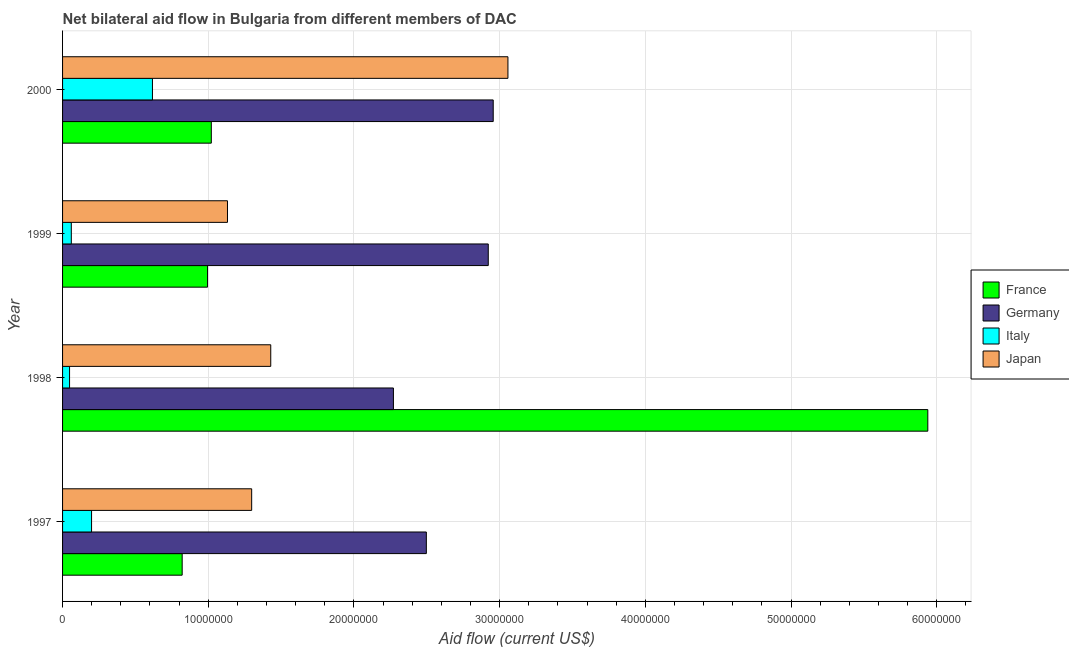How many different coloured bars are there?
Provide a succinct answer. 4. How many groups of bars are there?
Keep it short and to the point. 4. Are the number of bars per tick equal to the number of legend labels?
Your response must be concise. Yes. How many bars are there on the 2nd tick from the bottom?
Provide a succinct answer. 4. What is the label of the 3rd group of bars from the top?
Provide a short and direct response. 1998. In how many cases, is the number of bars for a given year not equal to the number of legend labels?
Provide a short and direct response. 0. What is the amount of aid given by france in 1999?
Give a very brief answer. 9.95e+06. Across all years, what is the maximum amount of aid given by france?
Ensure brevity in your answer.  5.94e+07. Across all years, what is the minimum amount of aid given by germany?
Give a very brief answer. 2.27e+07. In which year was the amount of aid given by germany maximum?
Ensure brevity in your answer.  2000. In which year was the amount of aid given by germany minimum?
Offer a very short reply. 1998. What is the total amount of aid given by italy in the graph?
Make the answer very short. 9.24e+06. What is the difference between the amount of aid given by italy in 1997 and that in 1998?
Provide a short and direct response. 1.51e+06. What is the difference between the amount of aid given by germany in 1997 and the amount of aid given by italy in 1999?
Make the answer very short. 2.44e+07. What is the average amount of aid given by germany per year?
Provide a succinct answer. 2.66e+07. In the year 1998, what is the difference between the amount of aid given by italy and amount of aid given by japan?
Give a very brief answer. -1.38e+07. In how many years, is the amount of aid given by japan greater than 24000000 US$?
Make the answer very short. 1. What is the ratio of the amount of aid given by germany in 1998 to that in 1999?
Offer a terse response. 0.78. Is the difference between the amount of aid given by germany in 1998 and 2000 greater than the difference between the amount of aid given by italy in 1998 and 2000?
Your answer should be compact. No. What is the difference between the highest and the second highest amount of aid given by france?
Give a very brief answer. 4.92e+07. What is the difference between the highest and the lowest amount of aid given by germany?
Provide a succinct answer. 6.85e+06. In how many years, is the amount of aid given by france greater than the average amount of aid given by france taken over all years?
Your answer should be very brief. 1. Is the sum of the amount of aid given by italy in 1997 and 2000 greater than the maximum amount of aid given by germany across all years?
Your answer should be compact. No. What does the 1st bar from the bottom in 2000 represents?
Your answer should be compact. France. How many bars are there?
Offer a terse response. 16. Are all the bars in the graph horizontal?
Provide a short and direct response. Yes. What is the difference between two consecutive major ticks on the X-axis?
Give a very brief answer. 1.00e+07. Does the graph contain any zero values?
Provide a short and direct response. No. Does the graph contain grids?
Make the answer very short. Yes. Where does the legend appear in the graph?
Provide a succinct answer. Center right. How many legend labels are there?
Offer a terse response. 4. What is the title of the graph?
Offer a very short reply. Net bilateral aid flow in Bulgaria from different members of DAC. What is the label or title of the Y-axis?
Your response must be concise. Year. What is the Aid flow (current US$) of France in 1997?
Offer a very short reply. 8.21e+06. What is the Aid flow (current US$) in Germany in 1997?
Give a very brief answer. 2.50e+07. What is the Aid flow (current US$) in Italy in 1997?
Your response must be concise. 1.99e+06. What is the Aid flow (current US$) in Japan in 1997?
Keep it short and to the point. 1.30e+07. What is the Aid flow (current US$) of France in 1998?
Offer a very short reply. 5.94e+07. What is the Aid flow (current US$) in Germany in 1998?
Offer a terse response. 2.27e+07. What is the Aid flow (current US$) in Japan in 1998?
Make the answer very short. 1.43e+07. What is the Aid flow (current US$) of France in 1999?
Keep it short and to the point. 9.95e+06. What is the Aid flow (current US$) in Germany in 1999?
Your answer should be very brief. 2.92e+07. What is the Aid flow (current US$) of Italy in 1999?
Offer a very short reply. 6.00e+05. What is the Aid flow (current US$) of Japan in 1999?
Keep it short and to the point. 1.13e+07. What is the Aid flow (current US$) of France in 2000?
Ensure brevity in your answer.  1.02e+07. What is the Aid flow (current US$) of Germany in 2000?
Your response must be concise. 2.96e+07. What is the Aid flow (current US$) of Italy in 2000?
Give a very brief answer. 6.17e+06. What is the Aid flow (current US$) in Japan in 2000?
Give a very brief answer. 3.06e+07. Across all years, what is the maximum Aid flow (current US$) of France?
Provide a short and direct response. 5.94e+07. Across all years, what is the maximum Aid flow (current US$) in Germany?
Offer a terse response. 2.96e+07. Across all years, what is the maximum Aid flow (current US$) of Italy?
Make the answer very short. 6.17e+06. Across all years, what is the maximum Aid flow (current US$) in Japan?
Make the answer very short. 3.06e+07. Across all years, what is the minimum Aid flow (current US$) of France?
Offer a terse response. 8.21e+06. Across all years, what is the minimum Aid flow (current US$) of Germany?
Keep it short and to the point. 2.27e+07. Across all years, what is the minimum Aid flow (current US$) in Italy?
Offer a very short reply. 4.80e+05. Across all years, what is the minimum Aid flow (current US$) in Japan?
Your answer should be very brief. 1.13e+07. What is the total Aid flow (current US$) of France in the graph?
Give a very brief answer. 8.78e+07. What is the total Aid flow (current US$) in Germany in the graph?
Ensure brevity in your answer.  1.06e+08. What is the total Aid flow (current US$) in Italy in the graph?
Make the answer very short. 9.24e+06. What is the total Aid flow (current US$) in Japan in the graph?
Provide a succinct answer. 6.92e+07. What is the difference between the Aid flow (current US$) of France in 1997 and that in 1998?
Provide a short and direct response. -5.12e+07. What is the difference between the Aid flow (current US$) of Germany in 1997 and that in 1998?
Offer a terse response. 2.26e+06. What is the difference between the Aid flow (current US$) in Italy in 1997 and that in 1998?
Provide a succinct answer. 1.51e+06. What is the difference between the Aid flow (current US$) of Japan in 1997 and that in 1998?
Provide a short and direct response. -1.31e+06. What is the difference between the Aid flow (current US$) of France in 1997 and that in 1999?
Provide a short and direct response. -1.74e+06. What is the difference between the Aid flow (current US$) in Germany in 1997 and that in 1999?
Offer a very short reply. -4.25e+06. What is the difference between the Aid flow (current US$) in Italy in 1997 and that in 1999?
Your answer should be compact. 1.39e+06. What is the difference between the Aid flow (current US$) in Japan in 1997 and that in 1999?
Your answer should be very brief. 1.66e+06. What is the difference between the Aid flow (current US$) of Germany in 1997 and that in 2000?
Offer a terse response. -4.59e+06. What is the difference between the Aid flow (current US$) in Italy in 1997 and that in 2000?
Give a very brief answer. -4.18e+06. What is the difference between the Aid flow (current US$) in Japan in 1997 and that in 2000?
Offer a very short reply. -1.76e+07. What is the difference between the Aid flow (current US$) of France in 1998 and that in 1999?
Provide a succinct answer. 4.94e+07. What is the difference between the Aid flow (current US$) in Germany in 1998 and that in 1999?
Offer a very short reply. -6.51e+06. What is the difference between the Aid flow (current US$) in Japan in 1998 and that in 1999?
Your response must be concise. 2.97e+06. What is the difference between the Aid flow (current US$) in France in 1998 and that in 2000?
Give a very brief answer. 4.92e+07. What is the difference between the Aid flow (current US$) in Germany in 1998 and that in 2000?
Keep it short and to the point. -6.85e+06. What is the difference between the Aid flow (current US$) in Italy in 1998 and that in 2000?
Provide a succinct answer. -5.69e+06. What is the difference between the Aid flow (current US$) in Japan in 1998 and that in 2000?
Provide a short and direct response. -1.63e+07. What is the difference between the Aid flow (current US$) of Italy in 1999 and that in 2000?
Offer a terse response. -5.57e+06. What is the difference between the Aid flow (current US$) in Japan in 1999 and that in 2000?
Keep it short and to the point. -1.92e+07. What is the difference between the Aid flow (current US$) of France in 1997 and the Aid flow (current US$) of Germany in 1998?
Give a very brief answer. -1.45e+07. What is the difference between the Aid flow (current US$) of France in 1997 and the Aid flow (current US$) of Italy in 1998?
Offer a very short reply. 7.73e+06. What is the difference between the Aid flow (current US$) in France in 1997 and the Aid flow (current US$) in Japan in 1998?
Your response must be concise. -6.08e+06. What is the difference between the Aid flow (current US$) in Germany in 1997 and the Aid flow (current US$) in Italy in 1998?
Offer a terse response. 2.45e+07. What is the difference between the Aid flow (current US$) of Germany in 1997 and the Aid flow (current US$) of Japan in 1998?
Provide a succinct answer. 1.07e+07. What is the difference between the Aid flow (current US$) of Italy in 1997 and the Aid flow (current US$) of Japan in 1998?
Your answer should be compact. -1.23e+07. What is the difference between the Aid flow (current US$) in France in 1997 and the Aid flow (current US$) in Germany in 1999?
Give a very brief answer. -2.10e+07. What is the difference between the Aid flow (current US$) in France in 1997 and the Aid flow (current US$) in Italy in 1999?
Ensure brevity in your answer.  7.61e+06. What is the difference between the Aid flow (current US$) in France in 1997 and the Aid flow (current US$) in Japan in 1999?
Offer a very short reply. -3.11e+06. What is the difference between the Aid flow (current US$) in Germany in 1997 and the Aid flow (current US$) in Italy in 1999?
Keep it short and to the point. 2.44e+07. What is the difference between the Aid flow (current US$) in Germany in 1997 and the Aid flow (current US$) in Japan in 1999?
Give a very brief answer. 1.36e+07. What is the difference between the Aid flow (current US$) of Italy in 1997 and the Aid flow (current US$) of Japan in 1999?
Ensure brevity in your answer.  -9.33e+06. What is the difference between the Aid flow (current US$) in France in 1997 and the Aid flow (current US$) in Germany in 2000?
Offer a very short reply. -2.14e+07. What is the difference between the Aid flow (current US$) in France in 1997 and the Aid flow (current US$) in Italy in 2000?
Your answer should be very brief. 2.04e+06. What is the difference between the Aid flow (current US$) of France in 1997 and the Aid flow (current US$) of Japan in 2000?
Keep it short and to the point. -2.24e+07. What is the difference between the Aid flow (current US$) of Germany in 1997 and the Aid flow (current US$) of Italy in 2000?
Provide a succinct answer. 1.88e+07. What is the difference between the Aid flow (current US$) of Germany in 1997 and the Aid flow (current US$) of Japan in 2000?
Make the answer very short. -5.60e+06. What is the difference between the Aid flow (current US$) of Italy in 1997 and the Aid flow (current US$) of Japan in 2000?
Make the answer very short. -2.86e+07. What is the difference between the Aid flow (current US$) in France in 1998 and the Aid flow (current US$) in Germany in 1999?
Make the answer very short. 3.02e+07. What is the difference between the Aid flow (current US$) of France in 1998 and the Aid flow (current US$) of Italy in 1999?
Make the answer very short. 5.88e+07. What is the difference between the Aid flow (current US$) in France in 1998 and the Aid flow (current US$) in Japan in 1999?
Provide a short and direct response. 4.81e+07. What is the difference between the Aid flow (current US$) in Germany in 1998 and the Aid flow (current US$) in Italy in 1999?
Keep it short and to the point. 2.21e+07. What is the difference between the Aid flow (current US$) in Germany in 1998 and the Aid flow (current US$) in Japan in 1999?
Keep it short and to the point. 1.14e+07. What is the difference between the Aid flow (current US$) in Italy in 1998 and the Aid flow (current US$) in Japan in 1999?
Make the answer very short. -1.08e+07. What is the difference between the Aid flow (current US$) in France in 1998 and the Aid flow (current US$) in Germany in 2000?
Provide a short and direct response. 2.98e+07. What is the difference between the Aid flow (current US$) in France in 1998 and the Aid flow (current US$) in Italy in 2000?
Keep it short and to the point. 5.32e+07. What is the difference between the Aid flow (current US$) of France in 1998 and the Aid flow (current US$) of Japan in 2000?
Give a very brief answer. 2.88e+07. What is the difference between the Aid flow (current US$) in Germany in 1998 and the Aid flow (current US$) in Italy in 2000?
Make the answer very short. 1.65e+07. What is the difference between the Aid flow (current US$) in Germany in 1998 and the Aid flow (current US$) in Japan in 2000?
Your answer should be very brief. -7.86e+06. What is the difference between the Aid flow (current US$) in Italy in 1998 and the Aid flow (current US$) in Japan in 2000?
Provide a short and direct response. -3.01e+07. What is the difference between the Aid flow (current US$) of France in 1999 and the Aid flow (current US$) of Germany in 2000?
Provide a succinct answer. -1.96e+07. What is the difference between the Aid flow (current US$) of France in 1999 and the Aid flow (current US$) of Italy in 2000?
Your response must be concise. 3.78e+06. What is the difference between the Aid flow (current US$) of France in 1999 and the Aid flow (current US$) of Japan in 2000?
Provide a succinct answer. -2.06e+07. What is the difference between the Aid flow (current US$) of Germany in 1999 and the Aid flow (current US$) of Italy in 2000?
Your response must be concise. 2.30e+07. What is the difference between the Aid flow (current US$) in Germany in 1999 and the Aid flow (current US$) in Japan in 2000?
Provide a short and direct response. -1.35e+06. What is the difference between the Aid flow (current US$) in Italy in 1999 and the Aid flow (current US$) in Japan in 2000?
Provide a succinct answer. -3.00e+07. What is the average Aid flow (current US$) of France per year?
Your response must be concise. 2.19e+07. What is the average Aid flow (current US$) of Germany per year?
Your answer should be compact. 2.66e+07. What is the average Aid flow (current US$) of Italy per year?
Give a very brief answer. 2.31e+06. What is the average Aid flow (current US$) of Japan per year?
Your response must be concise. 1.73e+07. In the year 1997, what is the difference between the Aid flow (current US$) of France and Aid flow (current US$) of Germany?
Make the answer very short. -1.68e+07. In the year 1997, what is the difference between the Aid flow (current US$) in France and Aid flow (current US$) in Italy?
Your response must be concise. 6.22e+06. In the year 1997, what is the difference between the Aid flow (current US$) in France and Aid flow (current US$) in Japan?
Your answer should be compact. -4.77e+06. In the year 1997, what is the difference between the Aid flow (current US$) of Germany and Aid flow (current US$) of Italy?
Provide a succinct answer. 2.30e+07. In the year 1997, what is the difference between the Aid flow (current US$) in Germany and Aid flow (current US$) in Japan?
Give a very brief answer. 1.20e+07. In the year 1997, what is the difference between the Aid flow (current US$) in Italy and Aid flow (current US$) in Japan?
Ensure brevity in your answer.  -1.10e+07. In the year 1998, what is the difference between the Aid flow (current US$) of France and Aid flow (current US$) of Germany?
Offer a terse response. 3.67e+07. In the year 1998, what is the difference between the Aid flow (current US$) in France and Aid flow (current US$) in Italy?
Your answer should be very brief. 5.89e+07. In the year 1998, what is the difference between the Aid flow (current US$) of France and Aid flow (current US$) of Japan?
Your answer should be compact. 4.51e+07. In the year 1998, what is the difference between the Aid flow (current US$) in Germany and Aid flow (current US$) in Italy?
Your answer should be compact. 2.22e+07. In the year 1998, what is the difference between the Aid flow (current US$) in Germany and Aid flow (current US$) in Japan?
Offer a very short reply. 8.42e+06. In the year 1998, what is the difference between the Aid flow (current US$) in Italy and Aid flow (current US$) in Japan?
Your answer should be very brief. -1.38e+07. In the year 1999, what is the difference between the Aid flow (current US$) of France and Aid flow (current US$) of Germany?
Your answer should be very brief. -1.93e+07. In the year 1999, what is the difference between the Aid flow (current US$) in France and Aid flow (current US$) in Italy?
Your answer should be very brief. 9.35e+06. In the year 1999, what is the difference between the Aid flow (current US$) in France and Aid flow (current US$) in Japan?
Your response must be concise. -1.37e+06. In the year 1999, what is the difference between the Aid flow (current US$) of Germany and Aid flow (current US$) of Italy?
Offer a terse response. 2.86e+07. In the year 1999, what is the difference between the Aid flow (current US$) in Germany and Aid flow (current US$) in Japan?
Offer a terse response. 1.79e+07. In the year 1999, what is the difference between the Aid flow (current US$) in Italy and Aid flow (current US$) in Japan?
Give a very brief answer. -1.07e+07. In the year 2000, what is the difference between the Aid flow (current US$) in France and Aid flow (current US$) in Germany?
Your answer should be compact. -1.94e+07. In the year 2000, what is the difference between the Aid flow (current US$) in France and Aid flow (current US$) in Italy?
Keep it short and to the point. 4.04e+06. In the year 2000, what is the difference between the Aid flow (current US$) in France and Aid flow (current US$) in Japan?
Your answer should be compact. -2.04e+07. In the year 2000, what is the difference between the Aid flow (current US$) in Germany and Aid flow (current US$) in Italy?
Offer a terse response. 2.34e+07. In the year 2000, what is the difference between the Aid flow (current US$) of Germany and Aid flow (current US$) of Japan?
Offer a terse response. -1.01e+06. In the year 2000, what is the difference between the Aid flow (current US$) in Italy and Aid flow (current US$) in Japan?
Provide a short and direct response. -2.44e+07. What is the ratio of the Aid flow (current US$) in France in 1997 to that in 1998?
Keep it short and to the point. 0.14. What is the ratio of the Aid flow (current US$) in Germany in 1997 to that in 1998?
Offer a terse response. 1.1. What is the ratio of the Aid flow (current US$) in Italy in 1997 to that in 1998?
Your answer should be compact. 4.15. What is the ratio of the Aid flow (current US$) of Japan in 1997 to that in 1998?
Your response must be concise. 0.91. What is the ratio of the Aid flow (current US$) in France in 1997 to that in 1999?
Make the answer very short. 0.83. What is the ratio of the Aid flow (current US$) in Germany in 1997 to that in 1999?
Keep it short and to the point. 0.85. What is the ratio of the Aid flow (current US$) in Italy in 1997 to that in 1999?
Make the answer very short. 3.32. What is the ratio of the Aid flow (current US$) in Japan in 1997 to that in 1999?
Offer a very short reply. 1.15. What is the ratio of the Aid flow (current US$) of France in 1997 to that in 2000?
Provide a succinct answer. 0.8. What is the ratio of the Aid flow (current US$) of Germany in 1997 to that in 2000?
Provide a succinct answer. 0.84. What is the ratio of the Aid flow (current US$) of Italy in 1997 to that in 2000?
Offer a very short reply. 0.32. What is the ratio of the Aid flow (current US$) of Japan in 1997 to that in 2000?
Offer a very short reply. 0.42. What is the ratio of the Aid flow (current US$) in France in 1998 to that in 1999?
Provide a succinct answer. 5.97. What is the ratio of the Aid flow (current US$) of Germany in 1998 to that in 1999?
Offer a very short reply. 0.78. What is the ratio of the Aid flow (current US$) in Italy in 1998 to that in 1999?
Provide a succinct answer. 0.8. What is the ratio of the Aid flow (current US$) in Japan in 1998 to that in 1999?
Offer a terse response. 1.26. What is the ratio of the Aid flow (current US$) of France in 1998 to that in 2000?
Your response must be concise. 5.82. What is the ratio of the Aid flow (current US$) of Germany in 1998 to that in 2000?
Your answer should be compact. 0.77. What is the ratio of the Aid flow (current US$) of Italy in 1998 to that in 2000?
Your answer should be compact. 0.08. What is the ratio of the Aid flow (current US$) in Japan in 1998 to that in 2000?
Offer a very short reply. 0.47. What is the ratio of the Aid flow (current US$) of France in 1999 to that in 2000?
Offer a terse response. 0.97. What is the ratio of the Aid flow (current US$) of Italy in 1999 to that in 2000?
Provide a succinct answer. 0.1. What is the ratio of the Aid flow (current US$) of Japan in 1999 to that in 2000?
Provide a succinct answer. 0.37. What is the difference between the highest and the second highest Aid flow (current US$) in France?
Provide a short and direct response. 4.92e+07. What is the difference between the highest and the second highest Aid flow (current US$) in Italy?
Offer a very short reply. 4.18e+06. What is the difference between the highest and the second highest Aid flow (current US$) of Japan?
Make the answer very short. 1.63e+07. What is the difference between the highest and the lowest Aid flow (current US$) of France?
Give a very brief answer. 5.12e+07. What is the difference between the highest and the lowest Aid flow (current US$) of Germany?
Provide a succinct answer. 6.85e+06. What is the difference between the highest and the lowest Aid flow (current US$) of Italy?
Your response must be concise. 5.69e+06. What is the difference between the highest and the lowest Aid flow (current US$) in Japan?
Your answer should be compact. 1.92e+07. 